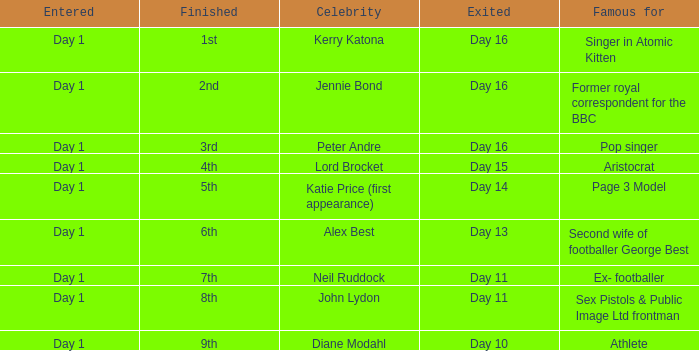Name the entered for famous for page 3 model Day 1. 